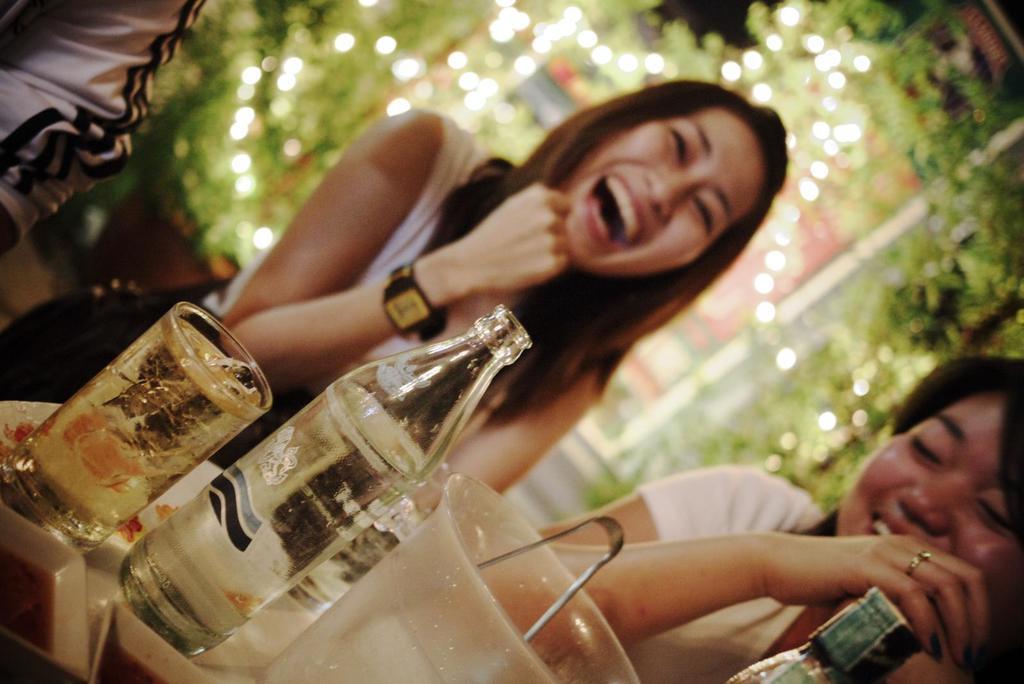Describe this image in one or two sentences. Background portion of the picture is blurry and we can see green leaves, lights and a pot. In this picture we can see people and they are smiling. Near to them we can see a plate, bottles, glass with drink in it, container and a tongs. On the left side we can see a person's hand. 